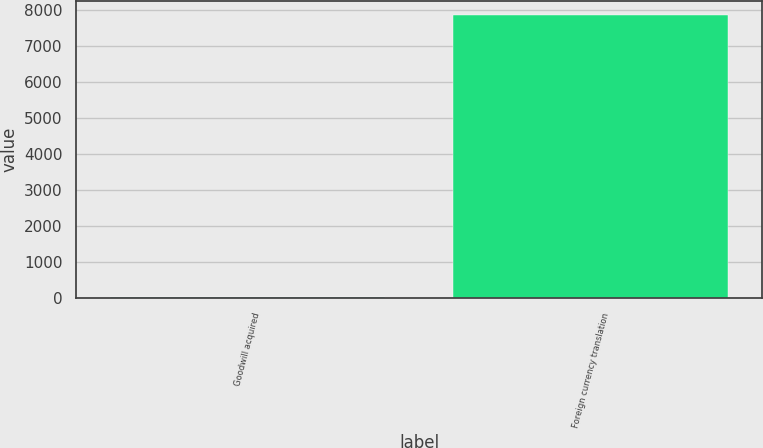<chart> <loc_0><loc_0><loc_500><loc_500><bar_chart><fcel>Goodwill acquired<fcel>Foreign currency translation<nl><fcel>30<fcel>7866<nl></chart> 